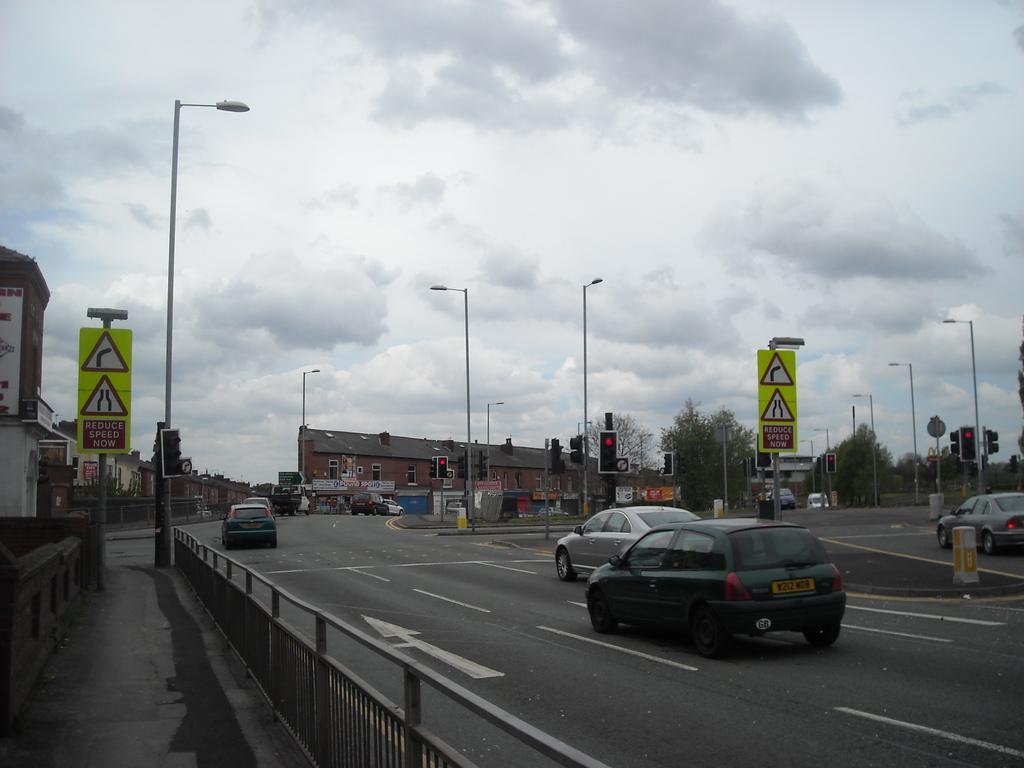How would you summarize this image in a sentence or two? This image is taken outdoors. At the top of the image there is a sky with clouds. At the bottom of the image there is a road. In the background there are a few buildings, trees, poles with street lights and there are many boards with text on them. On the left side of the image there are a few buildings and there is a signboard with a text in it. In the middle of the image a few cars are moving on the road and there is a railing. 